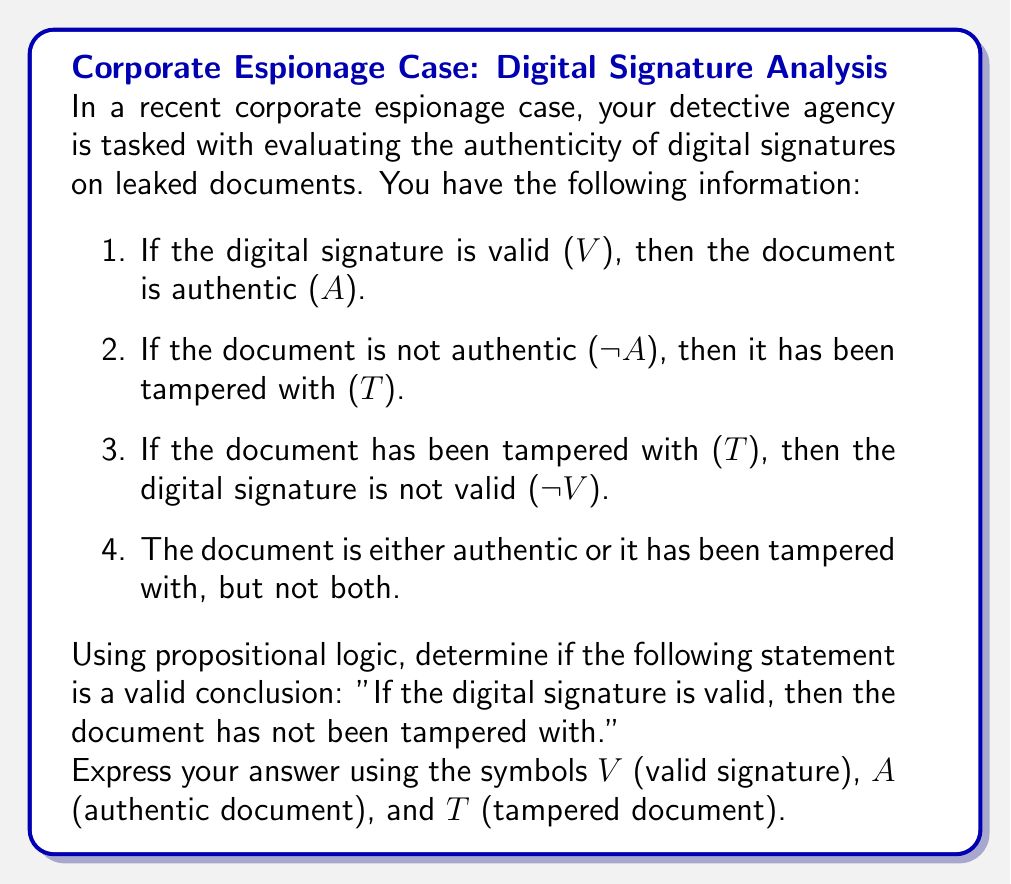What is the answer to this math problem? Let's approach this step-by-step using propositional logic:

1. First, let's formalize the given information:
   a. $V \rightarrow A$
   b. $\neg A \rightarrow T$
   c. $T \rightarrow \neg V$
   d. $A \oplus T$ (exclusive or)

2. We need to prove: $V \rightarrow \neg T$

3. Let's start with a proof by contradiction. Assume $V$ and $T$ are both true:
   
   $V \land T$

4. From (1c), we know that $T \rightarrow \neg V$. If $T$ is true, then $\neg V$ must be true:
   
   $\neg V$

5. But this contradicts our assumption that $V$ is true. Therefore, $V$ and $T$ cannot be true simultaneously.

6. From (1d), we know that either $A$ or $T$ must be true, but not both. Since $T$ cannot be true when $V$ is true, $A$ must be true when $V$ is true.

7. This confirms the original implication (1a): $V \rightarrow A$

8. Since $A$ and $T$ are mutually exclusive (1d), if $A$ is true, $T$ must be false.

9. Therefore, we can conclude: $V \rightarrow \neg T$

This proves that the statement "If the digital signature is valid, then the document has not been tampered with" is a valid conclusion based on the given information.
Answer: $V \rightarrow \neg T$ 